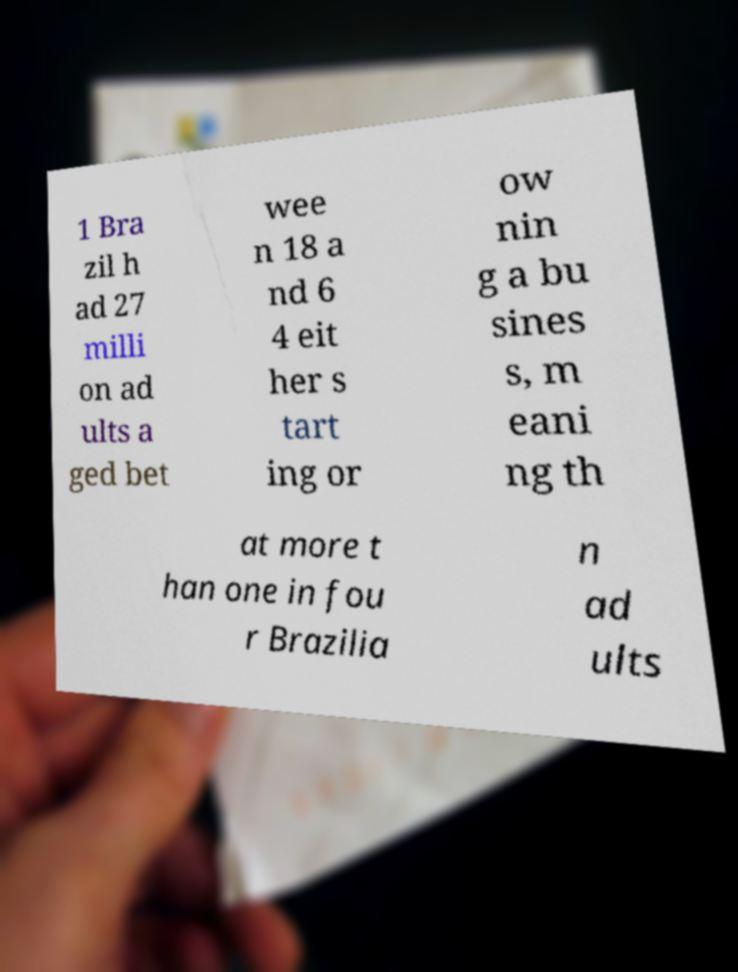There's text embedded in this image that I need extracted. Can you transcribe it verbatim? 1 Bra zil h ad 27 milli on ad ults a ged bet wee n 18 a nd 6 4 eit her s tart ing or ow nin g a bu sines s, m eani ng th at more t han one in fou r Brazilia n ad ults 